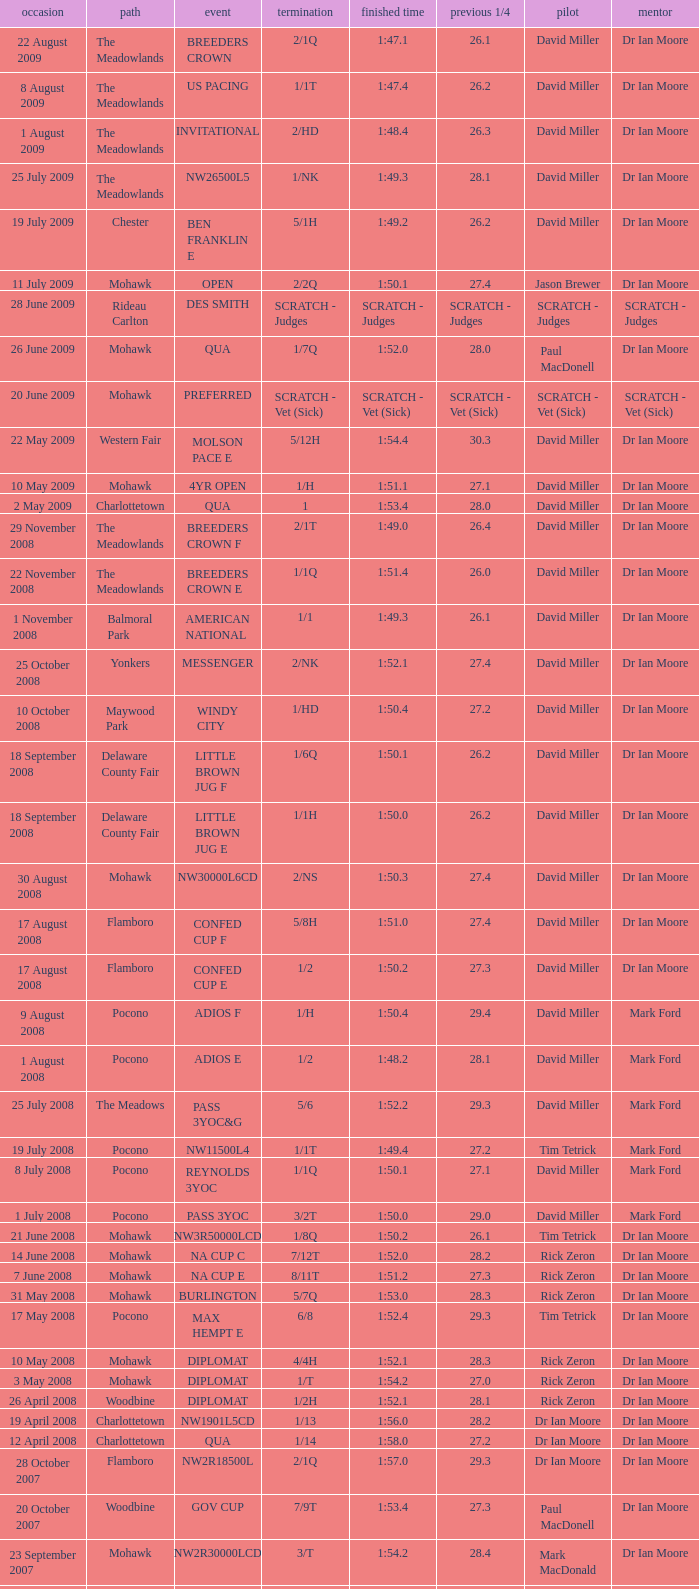What is the finishing time with a 2/1q finish on the Meadowlands track? 1:47.1. 